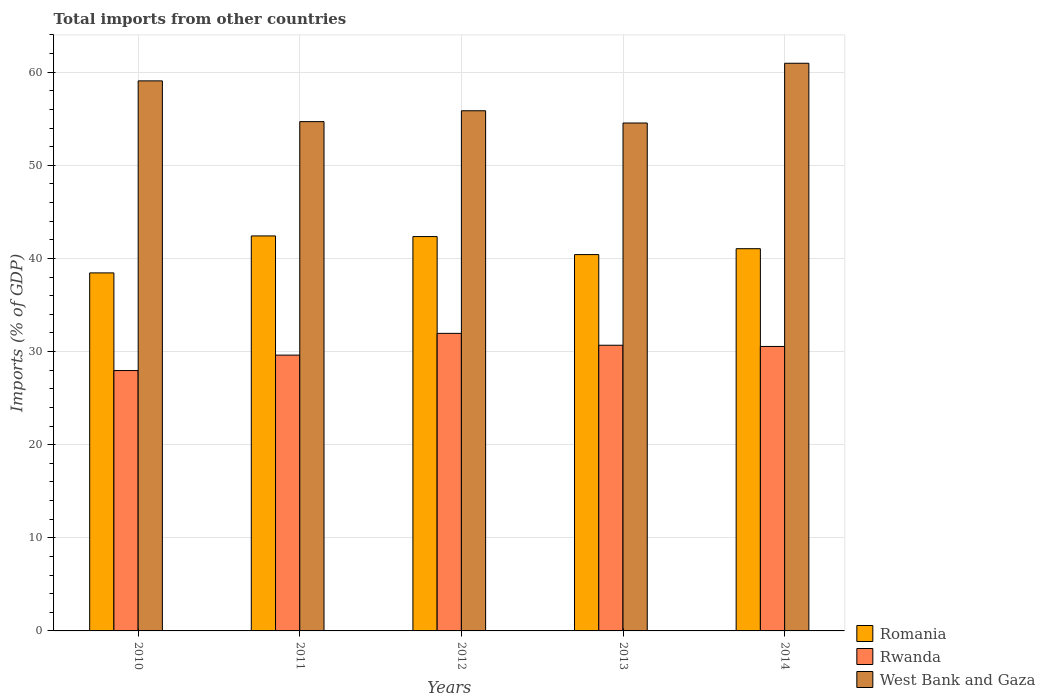How many different coloured bars are there?
Offer a terse response. 3. How many groups of bars are there?
Your answer should be compact. 5. Are the number of bars per tick equal to the number of legend labels?
Make the answer very short. Yes. In how many cases, is the number of bars for a given year not equal to the number of legend labels?
Your response must be concise. 0. What is the total imports in West Bank and Gaza in 2012?
Your response must be concise. 55.85. Across all years, what is the maximum total imports in Romania?
Your response must be concise. 42.41. Across all years, what is the minimum total imports in Rwanda?
Keep it short and to the point. 27.96. In which year was the total imports in Romania maximum?
Offer a very short reply. 2011. In which year was the total imports in Rwanda minimum?
Your answer should be compact. 2010. What is the total total imports in Romania in the graph?
Your response must be concise. 204.65. What is the difference between the total imports in Romania in 2012 and that in 2013?
Ensure brevity in your answer.  1.94. What is the difference between the total imports in Romania in 2014 and the total imports in Rwanda in 2012?
Give a very brief answer. 9.09. What is the average total imports in West Bank and Gaza per year?
Offer a very short reply. 57.02. In the year 2014, what is the difference between the total imports in West Bank and Gaza and total imports in Rwanda?
Your answer should be very brief. 30.41. In how many years, is the total imports in Rwanda greater than 60 %?
Keep it short and to the point. 0. What is the ratio of the total imports in West Bank and Gaza in 2010 to that in 2011?
Your answer should be very brief. 1.08. What is the difference between the highest and the second highest total imports in Romania?
Your answer should be very brief. 0.07. What is the difference between the highest and the lowest total imports in Romania?
Offer a terse response. 3.97. In how many years, is the total imports in Romania greater than the average total imports in Romania taken over all years?
Make the answer very short. 3. What does the 3rd bar from the left in 2011 represents?
Provide a short and direct response. West Bank and Gaza. What does the 3rd bar from the right in 2011 represents?
Your answer should be very brief. Romania. How many bars are there?
Keep it short and to the point. 15. Are all the bars in the graph horizontal?
Your answer should be compact. No. How many years are there in the graph?
Offer a very short reply. 5. Does the graph contain any zero values?
Give a very brief answer. No. How many legend labels are there?
Keep it short and to the point. 3. What is the title of the graph?
Keep it short and to the point. Total imports from other countries. What is the label or title of the Y-axis?
Provide a short and direct response. Imports (% of GDP). What is the Imports (% of GDP) of Romania in 2010?
Ensure brevity in your answer.  38.44. What is the Imports (% of GDP) in Rwanda in 2010?
Provide a short and direct response. 27.96. What is the Imports (% of GDP) in West Bank and Gaza in 2010?
Your answer should be very brief. 59.06. What is the Imports (% of GDP) in Romania in 2011?
Keep it short and to the point. 42.41. What is the Imports (% of GDP) in Rwanda in 2011?
Your answer should be compact. 29.62. What is the Imports (% of GDP) of West Bank and Gaza in 2011?
Your response must be concise. 54.69. What is the Imports (% of GDP) in Romania in 2012?
Provide a succinct answer. 42.34. What is the Imports (% of GDP) of Rwanda in 2012?
Provide a short and direct response. 31.95. What is the Imports (% of GDP) of West Bank and Gaza in 2012?
Your answer should be very brief. 55.85. What is the Imports (% of GDP) of Romania in 2013?
Make the answer very short. 40.41. What is the Imports (% of GDP) of Rwanda in 2013?
Your answer should be very brief. 30.67. What is the Imports (% of GDP) in West Bank and Gaza in 2013?
Your answer should be compact. 54.54. What is the Imports (% of GDP) in Romania in 2014?
Give a very brief answer. 41.04. What is the Imports (% of GDP) of Rwanda in 2014?
Ensure brevity in your answer.  30.54. What is the Imports (% of GDP) of West Bank and Gaza in 2014?
Your answer should be compact. 60.95. Across all years, what is the maximum Imports (% of GDP) in Romania?
Ensure brevity in your answer.  42.41. Across all years, what is the maximum Imports (% of GDP) in Rwanda?
Your response must be concise. 31.95. Across all years, what is the maximum Imports (% of GDP) of West Bank and Gaza?
Provide a succinct answer. 60.95. Across all years, what is the minimum Imports (% of GDP) of Romania?
Provide a short and direct response. 38.44. Across all years, what is the minimum Imports (% of GDP) in Rwanda?
Your answer should be compact. 27.96. Across all years, what is the minimum Imports (% of GDP) of West Bank and Gaza?
Give a very brief answer. 54.54. What is the total Imports (% of GDP) in Romania in the graph?
Give a very brief answer. 204.65. What is the total Imports (% of GDP) in Rwanda in the graph?
Your response must be concise. 150.74. What is the total Imports (% of GDP) of West Bank and Gaza in the graph?
Provide a short and direct response. 285.09. What is the difference between the Imports (% of GDP) in Romania in 2010 and that in 2011?
Your answer should be very brief. -3.97. What is the difference between the Imports (% of GDP) in Rwanda in 2010 and that in 2011?
Keep it short and to the point. -1.66. What is the difference between the Imports (% of GDP) of West Bank and Gaza in 2010 and that in 2011?
Your answer should be very brief. 4.38. What is the difference between the Imports (% of GDP) in Romania in 2010 and that in 2012?
Provide a short and direct response. -3.9. What is the difference between the Imports (% of GDP) in Rwanda in 2010 and that in 2012?
Provide a short and direct response. -3.99. What is the difference between the Imports (% of GDP) of West Bank and Gaza in 2010 and that in 2012?
Your answer should be very brief. 3.21. What is the difference between the Imports (% of GDP) of Romania in 2010 and that in 2013?
Your answer should be very brief. -1.97. What is the difference between the Imports (% of GDP) of Rwanda in 2010 and that in 2013?
Your answer should be very brief. -2.72. What is the difference between the Imports (% of GDP) in West Bank and Gaza in 2010 and that in 2013?
Your response must be concise. 4.53. What is the difference between the Imports (% of GDP) of Romania in 2010 and that in 2014?
Make the answer very short. -2.6. What is the difference between the Imports (% of GDP) in Rwanda in 2010 and that in 2014?
Make the answer very short. -2.59. What is the difference between the Imports (% of GDP) in West Bank and Gaza in 2010 and that in 2014?
Your answer should be very brief. -1.89. What is the difference between the Imports (% of GDP) in Romania in 2011 and that in 2012?
Ensure brevity in your answer.  0.07. What is the difference between the Imports (% of GDP) of Rwanda in 2011 and that in 2012?
Offer a very short reply. -2.34. What is the difference between the Imports (% of GDP) of West Bank and Gaza in 2011 and that in 2012?
Keep it short and to the point. -1.17. What is the difference between the Imports (% of GDP) of Romania in 2011 and that in 2013?
Your answer should be compact. 2. What is the difference between the Imports (% of GDP) in Rwanda in 2011 and that in 2013?
Your response must be concise. -1.06. What is the difference between the Imports (% of GDP) in West Bank and Gaza in 2011 and that in 2013?
Your response must be concise. 0.15. What is the difference between the Imports (% of GDP) of Romania in 2011 and that in 2014?
Make the answer very short. 1.37. What is the difference between the Imports (% of GDP) in Rwanda in 2011 and that in 2014?
Provide a short and direct response. -0.93. What is the difference between the Imports (% of GDP) of West Bank and Gaza in 2011 and that in 2014?
Make the answer very short. -6.27. What is the difference between the Imports (% of GDP) in Romania in 2012 and that in 2013?
Provide a short and direct response. 1.94. What is the difference between the Imports (% of GDP) in Rwanda in 2012 and that in 2013?
Give a very brief answer. 1.28. What is the difference between the Imports (% of GDP) of West Bank and Gaza in 2012 and that in 2013?
Your response must be concise. 1.32. What is the difference between the Imports (% of GDP) in Romania in 2012 and that in 2014?
Ensure brevity in your answer.  1.3. What is the difference between the Imports (% of GDP) in Rwanda in 2012 and that in 2014?
Make the answer very short. 1.41. What is the difference between the Imports (% of GDP) of West Bank and Gaza in 2012 and that in 2014?
Your response must be concise. -5.1. What is the difference between the Imports (% of GDP) of Romania in 2013 and that in 2014?
Ensure brevity in your answer.  -0.63. What is the difference between the Imports (% of GDP) of Rwanda in 2013 and that in 2014?
Your response must be concise. 0.13. What is the difference between the Imports (% of GDP) of West Bank and Gaza in 2013 and that in 2014?
Ensure brevity in your answer.  -6.42. What is the difference between the Imports (% of GDP) of Romania in 2010 and the Imports (% of GDP) of Rwanda in 2011?
Provide a short and direct response. 8.83. What is the difference between the Imports (% of GDP) in Romania in 2010 and the Imports (% of GDP) in West Bank and Gaza in 2011?
Offer a very short reply. -16.24. What is the difference between the Imports (% of GDP) in Rwanda in 2010 and the Imports (% of GDP) in West Bank and Gaza in 2011?
Offer a very short reply. -26.73. What is the difference between the Imports (% of GDP) in Romania in 2010 and the Imports (% of GDP) in Rwanda in 2012?
Your answer should be compact. 6.49. What is the difference between the Imports (% of GDP) in Romania in 2010 and the Imports (% of GDP) in West Bank and Gaza in 2012?
Keep it short and to the point. -17.41. What is the difference between the Imports (% of GDP) in Rwanda in 2010 and the Imports (% of GDP) in West Bank and Gaza in 2012?
Ensure brevity in your answer.  -27.9. What is the difference between the Imports (% of GDP) in Romania in 2010 and the Imports (% of GDP) in Rwanda in 2013?
Offer a very short reply. 7.77. What is the difference between the Imports (% of GDP) of Romania in 2010 and the Imports (% of GDP) of West Bank and Gaza in 2013?
Make the answer very short. -16.09. What is the difference between the Imports (% of GDP) in Rwanda in 2010 and the Imports (% of GDP) in West Bank and Gaza in 2013?
Give a very brief answer. -26.58. What is the difference between the Imports (% of GDP) of Romania in 2010 and the Imports (% of GDP) of Rwanda in 2014?
Make the answer very short. 7.9. What is the difference between the Imports (% of GDP) in Romania in 2010 and the Imports (% of GDP) in West Bank and Gaza in 2014?
Keep it short and to the point. -22.51. What is the difference between the Imports (% of GDP) of Rwanda in 2010 and the Imports (% of GDP) of West Bank and Gaza in 2014?
Ensure brevity in your answer.  -33. What is the difference between the Imports (% of GDP) of Romania in 2011 and the Imports (% of GDP) of Rwanda in 2012?
Offer a very short reply. 10.46. What is the difference between the Imports (% of GDP) of Romania in 2011 and the Imports (% of GDP) of West Bank and Gaza in 2012?
Give a very brief answer. -13.44. What is the difference between the Imports (% of GDP) of Rwanda in 2011 and the Imports (% of GDP) of West Bank and Gaza in 2012?
Ensure brevity in your answer.  -26.24. What is the difference between the Imports (% of GDP) in Romania in 2011 and the Imports (% of GDP) in Rwanda in 2013?
Your answer should be compact. 11.74. What is the difference between the Imports (% of GDP) of Romania in 2011 and the Imports (% of GDP) of West Bank and Gaza in 2013?
Offer a terse response. -12.12. What is the difference between the Imports (% of GDP) of Rwanda in 2011 and the Imports (% of GDP) of West Bank and Gaza in 2013?
Give a very brief answer. -24.92. What is the difference between the Imports (% of GDP) of Romania in 2011 and the Imports (% of GDP) of Rwanda in 2014?
Provide a short and direct response. 11.87. What is the difference between the Imports (% of GDP) of Romania in 2011 and the Imports (% of GDP) of West Bank and Gaza in 2014?
Your answer should be very brief. -18.54. What is the difference between the Imports (% of GDP) of Rwanda in 2011 and the Imports (% of GDP) of West Bank and Gaza in 2014?
Ensure brevity in your answer.  -31.34. What is the difference between the Imports (% of GDP) of Romania in 2012 and the Imports (% of GDP) of Rwanda in 2013?
Offer a very short reply. 11.67. What is the difference between the Imports (% of GDP) of Romania in 2012 and the Imports (% of GDP) of West Bank and Gaza in 2013?
Offer a very short reply. -12.19. What is the difference between the Imports (% of GDP) in Rwanda in 2012 and the Imports (% of GDP) in West Bank and Gaza in 2013?
Give a very brief answer. -22.59. What is the difference between the Imports (% of GDP) of Romania in 2012 and the Imports (% of GDP) of Rwanda in 2014?
Your answer should be compact. 11.8. What is the difference between the Imports (% of GDP) in Romania in 2012 and the Imports (% of GDP) in West Bank and Gaza in 2014?
Your response must be concise. -18.61. What is the difference between the Imports (% of GDP) of Rwanda in 2012 and the Imports (% of GDP) of West Bank and Gaza in 2014?
Ensure brevity in your answer.  -29. What is the difference between the Imports (% of GDP) in Romania in 2013 and the Imports (% of GDP) in Rwanda in 2014?
Make the answer very short. 9.86. What is the difference between the Imports (% of GDP) of Romania in 2013 and the Imports (% of GDP) of West Bank and Gaza in 2014?
Your answer should be very brief. -20.54. What is the difference between the Imports (% of GDP) in Rwanda in 2013 and the Imports (% of GDP) in West Bank and Gaza in 2014?
Make the answer very short. -30.28. What is the average Imports (% of GDP) in Romania per year?
Keep it short and to the point. 40.93. What is the average Imports (% of GDP) in Rwanda per year?
Your answer should be very brief. 30.15. What is the average Imports (% of GDP) in West Bank and Gaza per year?
Provide a short and direct response. 57.02. In the year 2010, what is the difference between the Imports (% of GDP) in Romania and Imports (% of GDP) in Rwanda?
Your answer should be compact. 10.49. In the year 2010, what is the difference between the Imports (% of GDP) of Romania and Imports (% of GDP) of West Bank and Gaza?
Offer a very short reply. -20.62. In the year 2010, what is the difference between the Imports (% of GDP) of Rwanda and Imports (% of GDP) of West Bank and Gaza?
Make the answer very short. -31.11. In the year 2011, what is the difference between the Imports (% of GDP) in Romania and Imports (% of GDP) in Rwanda?
Your answer should be very brief. 12.8. In the year 2011, what is the difference between the Imports (% of GDP) of Romania and Imports (% of GDP) of West Bank and Gaza?
Give a very brief answer. -12.27. In the year 2011, what is the difference between the Imports (% of GDP) in Rwanda and Imports (% of GDP) in West Bank and Gaza?
Provide a succinct answer. -25.07. In the year 2012, what is the difference between the Imports (% of GDP) in Romania and Imports (% of GDP) in Rwanda?
Make the answer very short. 10.39. In the year 2012, what is the difference between the Imports (% of GDP) in Romania and Imports (% of GDP) in West Bank and Gaza?
Keep it short and to the point. -13.51. In the year 2012, what is the difference between the Imports (% of GDP) in Rwanda and Imports (% of GDP) in West Bank and Gaza?
Your answer should be compact. -23.9. In the year 2013, what is the difference between the Imports (% of GDP) in Romania and Imports (% of GDP) in Rwanda?
Provide a succinct answer. 9.73. In the year 2013, what is the difference between the Imports (% of GDP) in Romania and Imports (% of GDP) in West Bank and Gaza?
Your answer should be very brief. -14.13. In the year 2013, what is the difference between the Imports (% of GDP) of Rwanda and Imports (% of GDP) of West Bank and Gaza?
Provide a short and direct response. -23.86. In the year 2014, what is the difference between the Imports (% of GDP) in Romania and Imports (% of GDP) in Rwanda?
Your answer should be compact. 10.5. In the year 2014, what is the difference between the Imports (% of GDP) in Romania and Imports (% of GDP) in West Bank and Gaza?
Your answer should be compact. -19.91. In the year 2014, what is the difference between the Imports (% of GDP) of Rwanda and Imports (% of GDP) of West Bank and Gaza?
Provide a succinct answer. -30.41. What is the ratio of the Imports (% of GDP) of Romania in 2010 to that in 2011?
Keep it short and to the point. 0.91. What is the ratio of the Imports (% of GDP) of Rwanda in 2010 to that in 2011?
Your response must be concise. 0.94. What is the ratio of the Imports (% of GDP) in Romania in 2010 to that in 2012?
Offer a very short reply. 0.91. What is the ratio of the Imports (% of GDP) of West Bank and Gaza in 2010 to that in 2012?
Your answer should be very brief. 1.06. What is the ratio of the Imports (% of GDP) in Romania in 2010 to that in 2013?
Your answer should be very brief. 0.95. What is the ratio of the Imports (% of GDP) of Rwanda in 2010 to that in 2013?
Make the answer very short. 0.91. What is the ratio of the Imports (% of GDP) in West Bank and Gaza in 2010 to that in 2013?
Ensure brevity in your answer.  1.08. What is the ratio of the Imports (% of GDP) in Romania in 2010 to that in 2014?
Provide a short and direct response. 0.94. What is the ratio of the Imports (% of GDP) of Rwanda in 2010 to that in 2014?
Your answer should be very brief. 0.92. What is the ratio of the Imports (% of GDP) in Rwanda in 2011 to that in 2012?
Keep it short and to the point. 0.93. What is the ratio of the Imports (% of GDP) of West Bank and Gaza in 2011 to that in 2012?
Ensure brevity in your answer.  0.98. What is the ratio of the Imports (% of GDP) of Romania in 2011 to that in 2013?
Your answer should be compact. 1.05. What is the ratio of the Imports (% of GDP) in Rwanda in 2011 to that in 2013?
Your answer should be compact. 0.97. What is the ratio of the Imports (% of GDP) of Romania in 2011 to that in 2014?
Make the answer very short. 1.03. What is the ratio of the Imports (% of GDP) in Rwanda in 2011 to that in 2014?
Give a very brief answer. 0.97. What is the ratio of the Imports (% of GDP) of West Bank and Gaza in 2011 to that in 2014?
Ensure brevity in your answer.  0.9. What is the ratio of the Imports (% of GDP) in Romania in 2012 to that in 2013?
Your response must be concise. 1.05. What is the ratio of the Imports (% of GDP) of Rwanda in 2012 to that in 2013?
Offer a terse response. 1.04. What is the ratio of the Imports (% of GDP) in West Bank and Gaza in 2012 to that in 2013?
Provide a short and direct response. 1.02. What is the ratio of the Imports (% of GDP) of Romania in 2012 to that in 2014?
Your answer should be compact. 1.03. What is the ratio of the Imports (% of GDP) of Rwanda in 2012 to that in 2014?
Provide a short and direct response. 1.05. What is the ratio of the Imports (% of GDP) in West Bank and Gaza in 2012 to that in 2014?
Provide a succinct answer. 0.92. What is the ratio of the Imports (% of GDP) in Romania in 2013 to that in 2014?
Your answer should be very brief. 0.98. What is the ratio of the Imports (% of GDP) in West Bank and Gaza in 2013 to that in 2014?
Keep it short and to the point. 0.89. What is the difference between the highest and the second highest Imports (% of GDP) of Romania?
Keep it short and to the point. 0.07. What is the difference between the highest and the second highest Imports (% of GDP) in Rwanda?
Offer a terse response. 1.28. What is the difference between the highest and the second highest Imports (% of GDP) of West Bank and Gaza?
Ensure brevity in your answer.  1.89. What is the difference between the highest and the lowest Imports (% of GDP) of Romania?
Provide a short and direct response. 3.97. What is the difference between the highest and the lowest Imports (% of GDP) in Rwanda?
Your answer should be compact. 3.99. What is the difference between the highest and the lowest Imports (% of GDP) in West Bank and Gaza?
Give a very brief answer. 6.42. 